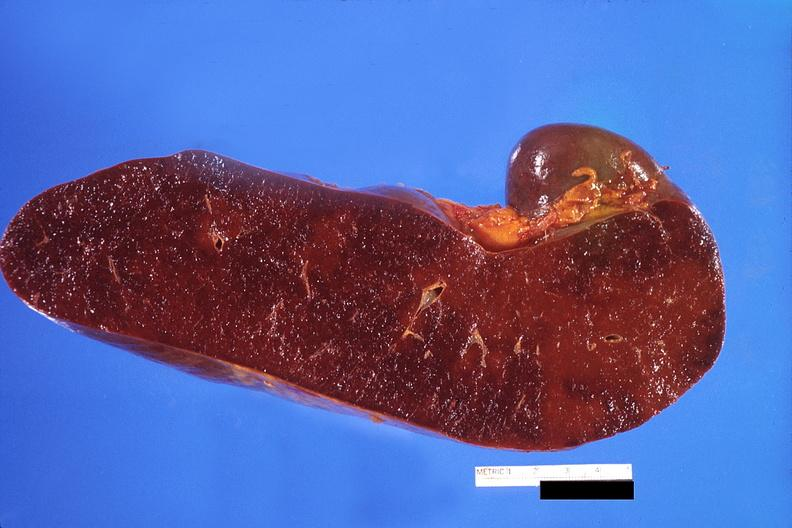does this image show spleen, congestion?
Answer the question using a single word or phrase. Yes 